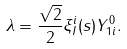<formula> <loc_0><loc_0><loc_500><loc_500>\lambda = \frac { \sqrt { 2 } } { 2 } \xi _ { I } ^ { i } ( s ) Y _ { 1 i } ^ { 0 } .</formula> 